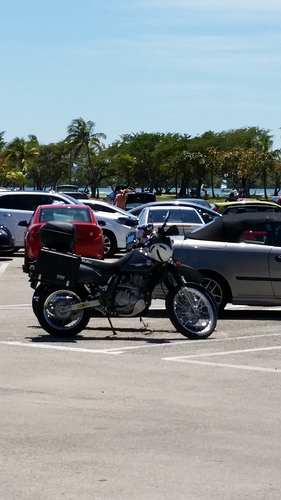<image>
Is there a sky behind the trees? Yes. From this viewpoint, the sky is positioned behind the trees, with the trees partially or fully occluding the sky. 